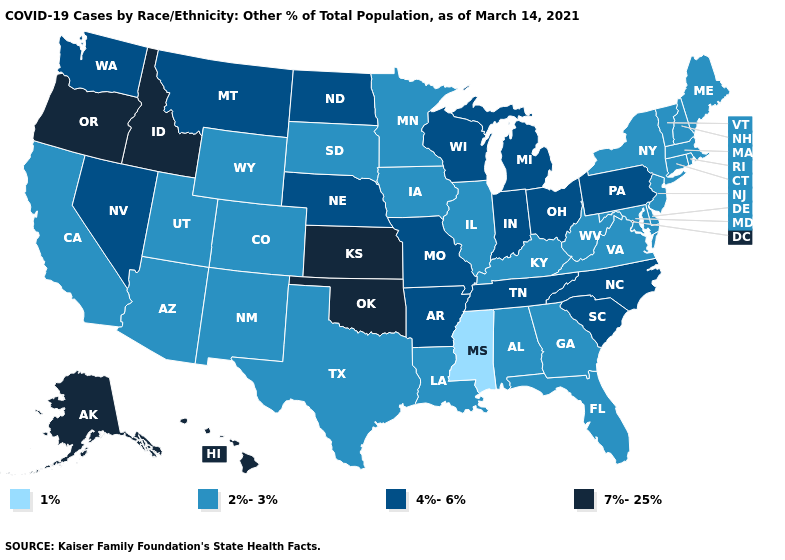What is the highest value in the USA?
Concise answer only. 7%-25%. Among the states that border Kentucky , does Ohio have the lowest value?
Concise answer only. No. Does New Hampshire have a lower value than Texas?
Keep it brief. No. What is the lowest value in the Northeast?
Answer briefly. 2%-3%. What is the highest value in the West ?
Write a very short answer. 7%-25%. Does the map have missing data?
Be succinct. No. Does Maine have the lowest value in the USA?
Be succinct. No. Does Virginia have the same value as Massachusetts?
Quick response, please. Yes. Which states have the lowest value in the USA?
Give a very brief answer. Mississippi. What is the value of Alabama?
Answer briefly. 2%-3%. Which states have the lowest value in the USA?
Be succinct. Mississippi. What is the lowest value in the MidWest?
Give a very brief answer. 2%-3%. Does New Jersey have the highest value in the USA?
Short answer required. No. What is the lowest value in the South?
Be succinct. 1%. Does the map have missing data?
Keep it brief. No. 